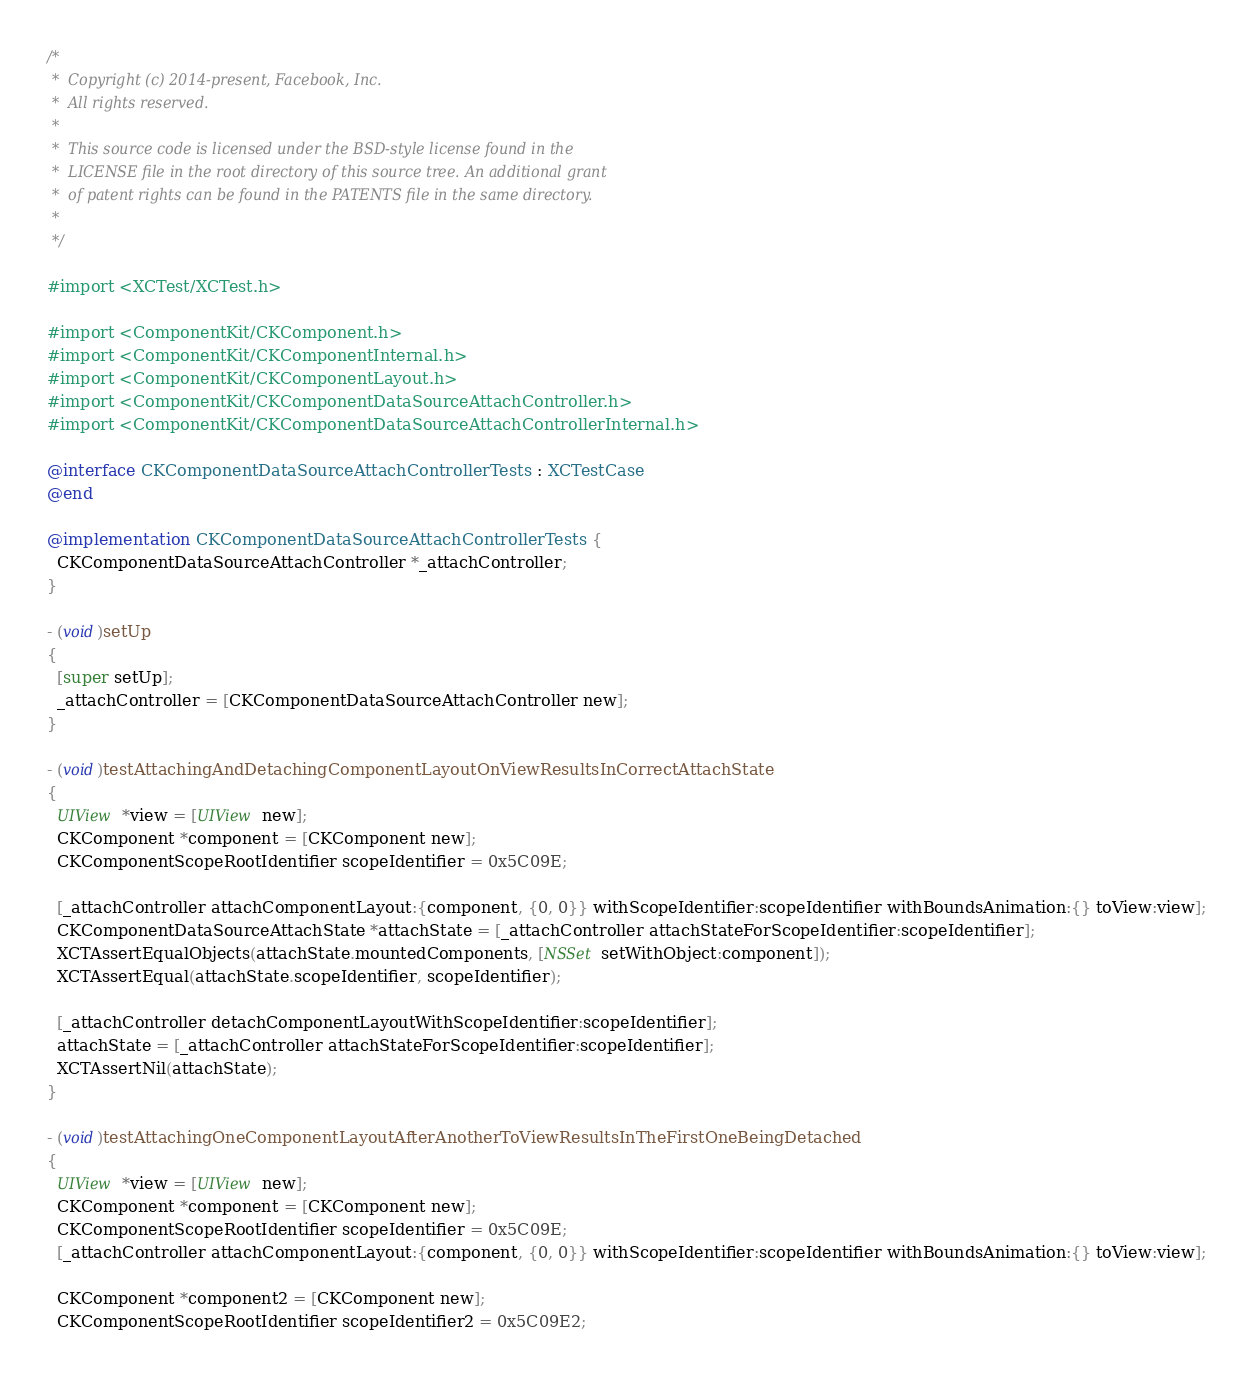<code> <loc_0><loc_0><loc_500><loc_500><_ObjectiveC_>/*
 *  Copyright (c) 2014-present, Facebook, Inc.
 *  All rights reserved.
 *
 *  This source code is licensed under the BSD-style license found in the
 *  LICENSE file in the root directory of this source tree. An additional grant
 *  of patent rights can be found in the PATENTS file in the same directory.
 *
 */

#import <XCTest/XCTest.h>

#import <ComponentKit/CKComponent.h>
#import <ComponentKit/CKComponentInternal.h>
#import <ComponentKit/CKComponentLayout.h>
#import <ComponentKit/CKComponentDataSourceAttachController.h>
#import <ComponentKit/CKComponentDataSourceAttachControllerInternal.h>

@interface CKComponentDataSourceAttachControllerTests : XCTestCase
@end

@implementation CKComponentDataSourceAttachControllerTests {
  CKComponentDataSourceAttachController *_attachController;
}

- (void)setUp
{
  [super setUp];
  _attachController = [CKComponentDataSourceAttachController new];
}

- (void)testAttachingAndDetachingComponentLayoutOnViewResultsInCorrectAttachState
{
  UIView *view = [UIView new];
  CKComponent *component = [CKComponent new];
  CKComponentScopeRootIdentifier scopeIdentifier = 0x5C09E;

  [_attachController attachComponentLayout:{component, {0, 0}} withScopeIdentifier:scopeIdentifier withBoundsAnimation:{} toView:view];
  CKComponentDataSourceAttachState *attachState = [_attachController attachStateForScopeIdentifier:scopeIdentifier];
  XCTAssertEqualObjects(attachState.mountedComponents, [NSSet setWithObject:component]);
  XCTAssertEqual(attachState.scopeIdentifier, scopeIdentifier);

  [_attachController detachComponentLayoutWithScopeIdentifier:scopeIdentifier];
  attachState = [_attachController attachStateForScopeIdentifier:scopeIdentifier];
  XCTAssertNil(attachState);
}

- (void)testAttachingOneComponentLayoutAfterAnotherToViewResultsInTheFirstOneBeingDetached
{
  UIView *view = [UIView new];
  CKComponent *component = [CKComponent new];
  CKComponentScopeRootIdentifier scopeIdentifier = 0x5C09E;
  [_attachController attachComponentLayout:{component, {0, 0}} withScopeIdentifier:scopeIdentifier withBoundsAnimation:{} toView:view];

  CKComponent *component2 = [CKComponent new];
  CKComponentScopeRootIdentifier scopeIdentifier2 = 0x5C09E2;</code> 